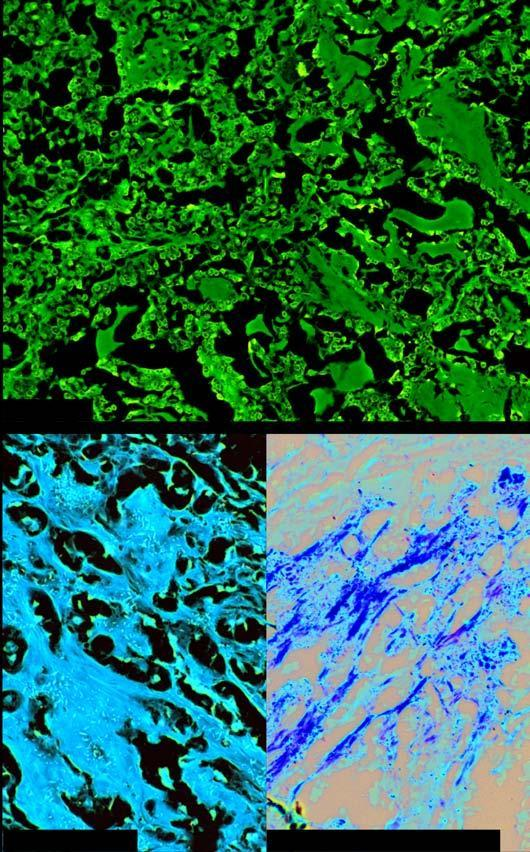what shows congophilia which depicts apple-green birefringence under polarising microscopy?
Answer the question using a single word or phrase. Amyloid 